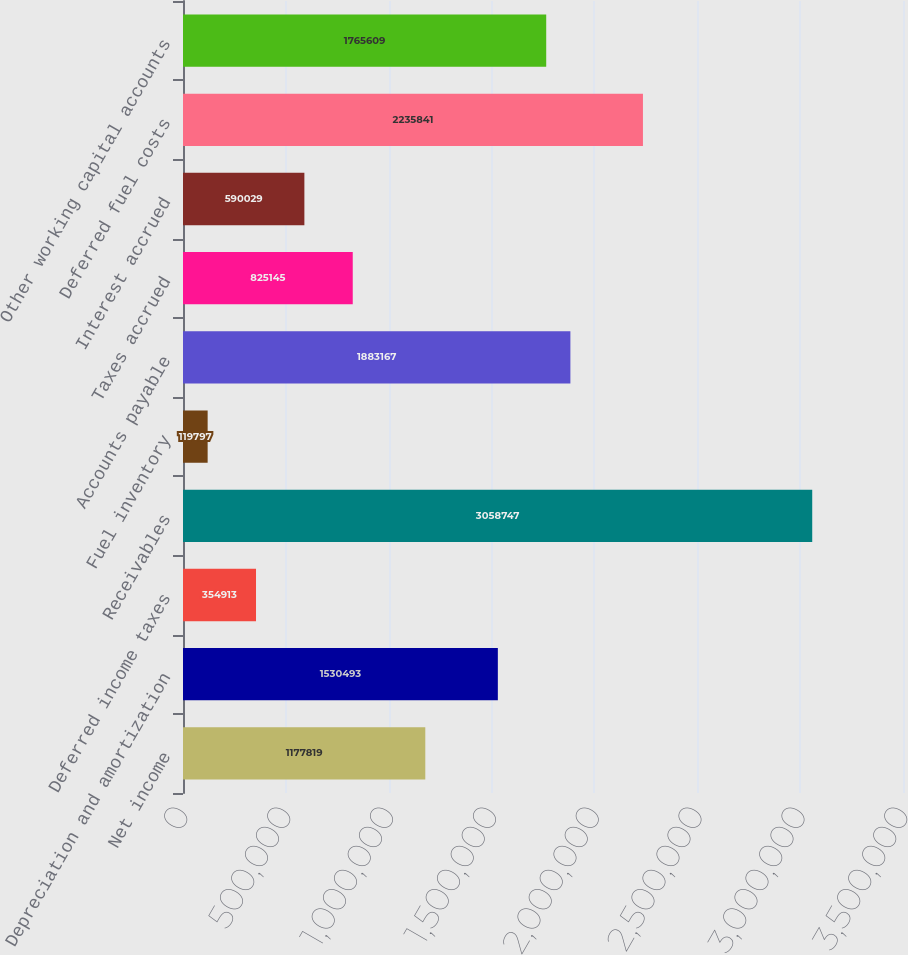Convert chart to OTSL. <chart><loc_0><loc_0><loc_500><loc_500><bar_chart><fcel>Net income<fcel>Depreciation and amortization<fcel>Deferred income taxes<fcel>Receivables<fcel>Fuel inventory<fcel>Accounts payable<fcel>Taxes accrued<fcel>Interest accrued<fcel>Deferred fuel costs<fcel>Other working capital accounts<nl><fcel>1.17782e+06<fcel>1.53049e+06<fcel>354913<fcel>3.05875e+06<fcel>119797<fcel>1.88317e+06<fcel>825145<fcel>590029<fcel>2.23584e+06<fcel>1.76561e+06<nl></chart> 